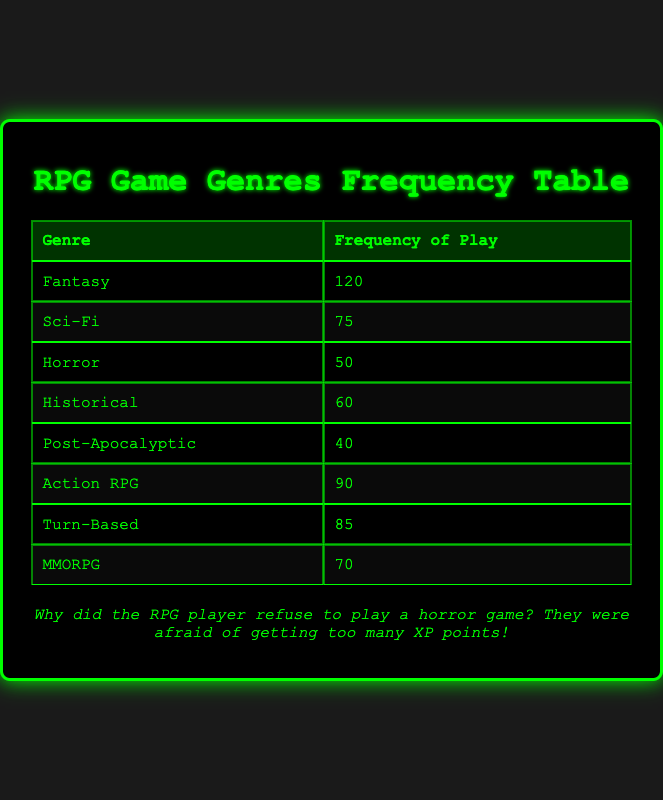What is the genre with the highest frequency of play? Looking at the table, "Fantasy" has the highest frequency with 120.
Answer: Fantasy How many players enjoy "Sci-Fi" RPGs? The table shows that 75 players enjoy "Sci-Fi" RPGs.
Answer: 75 Is "Post-Apocalyptic" the least played genre? The "Post-Apocalyptic" genre has a frequency of 40, which is lower than all other genres listed, confirming it is the least played.
Answer: Yes What is the total frequency of play for "Turn-Based" and "Horror" genres combined? Adding "Turn-Based" (85) and "Horror" (50) gives us 85 + 50 = 135.
Answer: 135 Which genre has a frequency of play that is closest to 70? "MMORPG" is exactly 70, which matches the requested value.
Answer: MMORPG What is the average frequency of play for all genres listed in the table? Adding the frequencies (120 + 75 + 50 + 60 + 40 + 90 + 85 + 70) gives a total of 690. There are 8 genres, so dividing gives us 690 / 8 = 86.25.
Answer: 86.25 Is it true that "Action RPG" is played more frequently than "Historical"? "Action RPG" has a frequency of 90, while "Historical" has 60, so indeed "Action RPG" is played more frequently.
Answer: Yes If we compare "Fantasy" and the combined total of "Sci-Fi" and "Horror", how much more frequently is "Fantasy" played? "Fantasy" has 120 while "Sci-Fi" has 75 and "Horror" has 50. Their combined total is 75 + 50 = 125. Therefore, 120 - 125 = -5, indicating "Fantasy" is played less frequently.
Answer: No What percentage of players prefer "Turn-Based" RPGs compared to the total frequency of all genres? The total frequency of all genres is 690. The percentage for "Turn-Based" is (85 / 690) * 100, which equals approximately 12.32%.
Answer: 12.32% 